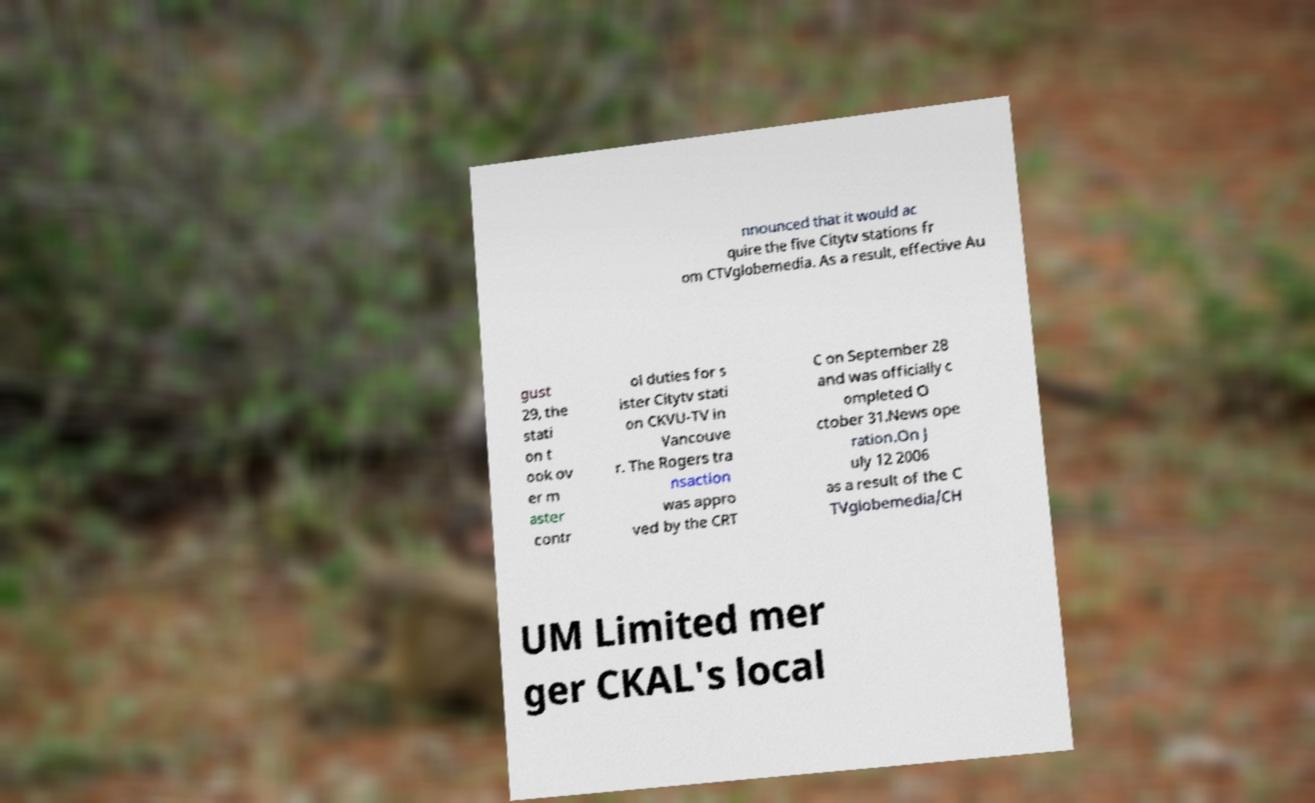What messages or text are displayed in this image? I need them in a readable, typed format. nnounced that it would ac quire the five Citytv stations fr om CTVglobemedia. As a result, effective Au gust 29, the stati on t ook ov er m aster contr ol duties for s ister Citytv stati on CKVU-TV in Vancouve r. The Rogers tra nsaction was appro ved by the CRT C on September 28 and was officially c ompleted O ctober 31.News ope ration.On J uly 12 2006 as a result of the C TVglobemedia/CH UM Limited mer ger CKAL's local 